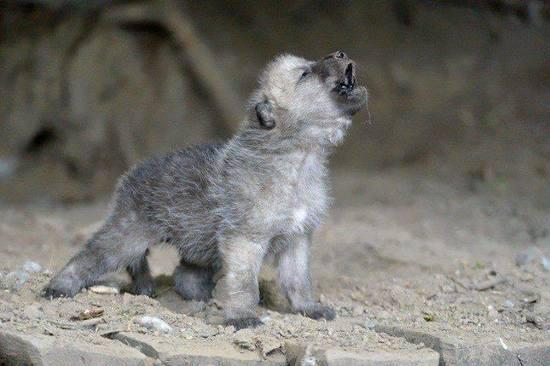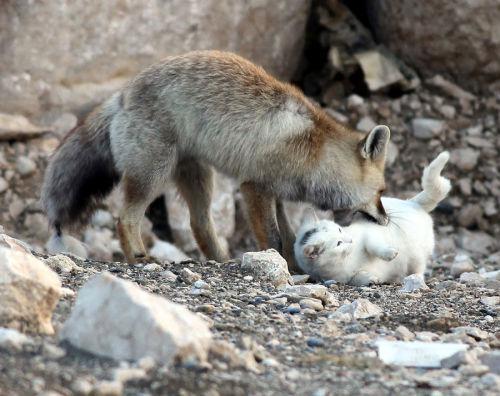The first image is the image on the left, the second image is the image on the right. Assess this claim about the two images: "An image shows a wolf walking forward, in the general direction of the camera.". Correct or not? Answer yes or no. No. 